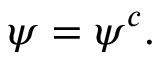<formula> <loc_0><loc_0><loc_500><loc_500>\psi = \psi ^ { c } .</formula> 